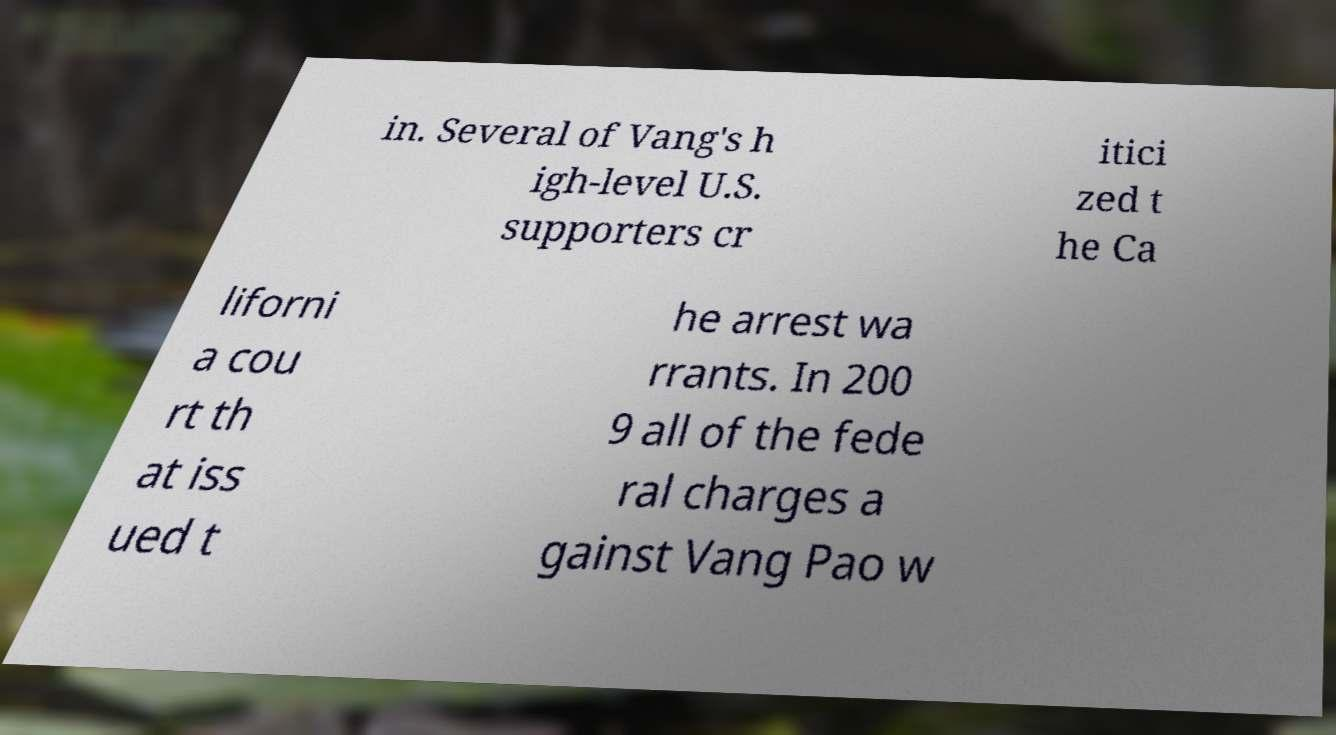What messages or text are displayed in this image? I need them in a readable, typed format. in. Several of Vang's h igh-level U.S. supporters cr itici zed t he Ca liforni a cou rt th at iss ued t he arrest wa rrants. In 200 9 all of the fede ral charges a gainst Vang Pao w 